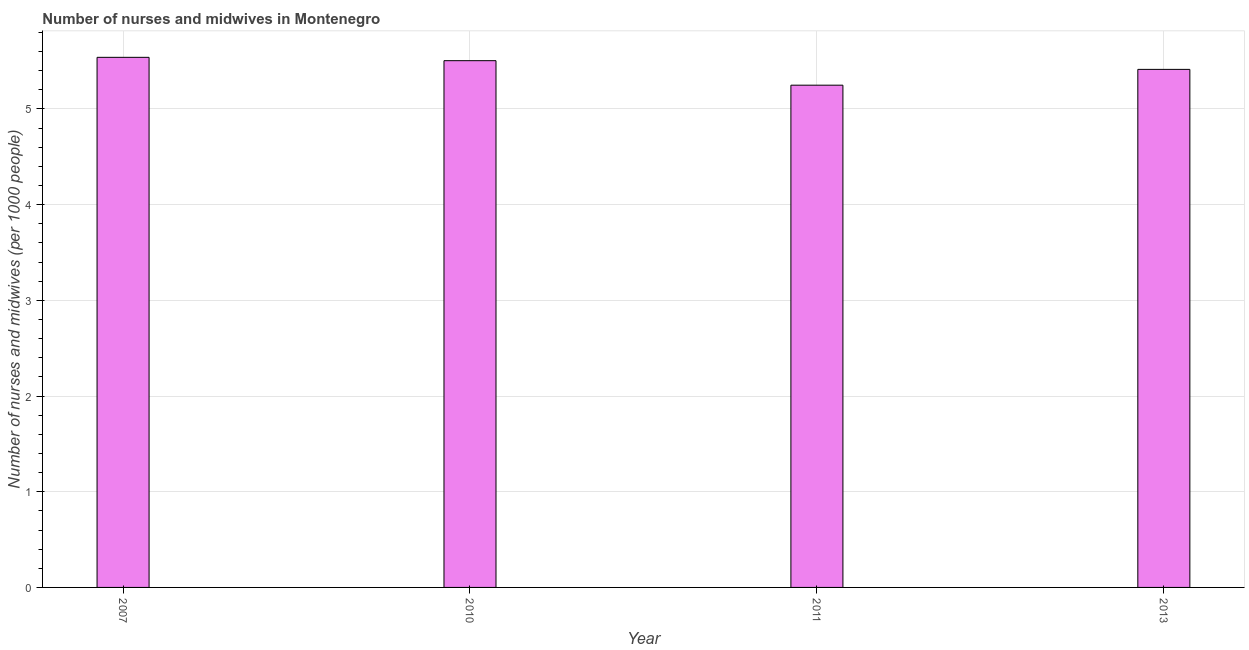Does the graph contain any zero values?
Offer a terse response. No. Does the graph contain grids?
Ensure brevity in your answer.  Yes. What is the title of the graph?
Keep it short and to the point. Number of nurses and midwives in Montenegro. What is the label or title of the Y-axis?
Keep it short and to the point. Number of nurses and midwives (per 1000 people). What is the number of nurses and midwives in 2011?
Provide a succinct answer. 5.25. Across all years, what is the maximum number of nurses and midwives?
Provide a succinct answer. 5.54. Across all years, what is the minimum number of nurses and midwives?
Provide a short and direct response. 5.25. What is the sum of the number of nurses and midwives?
Provide a succinct answer. 21.71. What is the difference between the number of nurses and midwives in 2007 and 2013?
Offer a very short reply. 0.13. What is the average number of nurses and midwives per year?
Ensure brevity in your answer.  5.43. What is the median number of nurses and midwives?
Offer a terse response. 5.46. In how many years, is the number of nurses and midwives greater than 0.6 ?
Keep it short and to the point. 4. What is the ratio of the number of nurses and midwives in 2011 to that in 2013?
Keep it short and to the point. 0.97. What is the difference between the highest and the second highest number of nurses and midwives?
Your answer should be very brief. 0.04. What is the difference between the highest and the lowest number of nurses and midwives?
Offer a terse response. 0.29. How many bars are there?
Make the answer very short. 4. Are all the bars in the graph horizontal?
Provide a short and direct response. No. What is the Number of nurses and midwives (per 1000 people) in 2007?
Your answer should be compact. 5.54. What is the Number of nurses and midwives (per 1000 people) of 2010?
Provide a short and direct response. 5.5. What is the Number of nurses and midwives (per 1000 people) of 2011?
Make the answer very short. 5.25. What is the Number of nurses and midwives (per 1000 people) in 2013?
Provide a short and direct response. 5.41. What is the difference between the Number of nurses and midwives (per 1000 people) in 2007 and 2010?
Make the answer very short. 0.04. What is the difference between the Number of nurses and midwives (per 1000 people) in 2007 and 2011?
Ensure brevity in your answer.  0.29. What is the difference between the Number of nurses and midwives (per 1000 people) in 2007 and 2013?
Your answer should be very brief. 0.13. What is the difference between the Number of nurses and midwives (per 1000 people) in 2010 and 2011?
Keep it short and to the point. 0.26. What is the difference between the Number of nurses and midwives (per 1000 people) in 2010 and 2013?
Give a very brief answer. 0.09. What is the difference between the Number of nurses and midwives (per 1000 people) in 2011 and 2013?
Ensure brevity in your answer.  -0.17. What is the ratio of the Number of nurses and midwives (per 1000 people) in 2007 to that in 2011?
Give a very brief answer. 1.05. What is the ratio of the Number of nurses and midwives (per 1000 people) in 2010 to that in 2011?
Your answer should be compact. 1.05. What is the ratio of the Number of nurses and midwives (per 1000 people) in 2011 to that in 2013?
Offer a terse response. 0.97. 